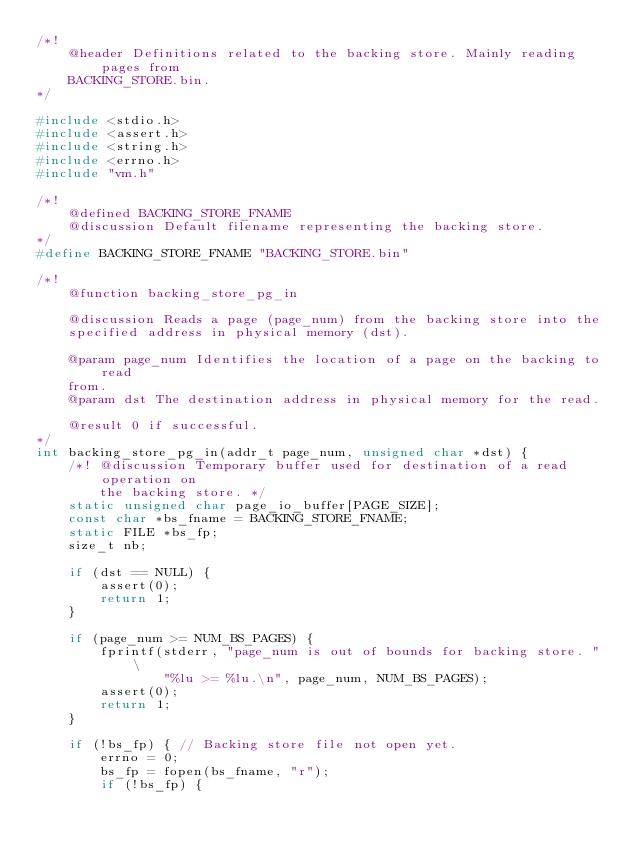<code> <loc_0><loc_0><loc_500><loc_500><_C_>/*!
    @header Definitions related to the backing store. Mainly reading pages from
    BACKING_STORE.bin.
*/

#include <stdio.h>
#include <assert.h>
#include <string.h>
#include <errno.h>
#include "vm.h"

/*!
    @defined BACKING_STORE_FNAME
    @discussion Default filename representing the backing store.
*/
#define BACKING_STORE_FNAME "BACKING_STORE.bin"

/*!
    @function backing_store_pg_in

    @discussion Reads a page (page_num) from the backing store into the
    specified address in physical memory (dst).

    @param page_num Identifies the location of a page on the backing to read
    from.
    @param dst The destination address in physical memory for the read.

    @result 0 if successful.
*/
int backing_store_pg_in(addr_t page_num, unsigned char *dst) {
    /*! @discussion Temporary buffer used for destination of a read operation on
        the backing store. */
    static unsigned char page_io_buffer[PAGE_SIZE];
    const char *bs_fname = BACKING_STORE_FNAME;
    static FILE *bs_fp;
    size_t nb;

    if (dst == NULL) {
        assert(0);
        return 1;
    }

    if (page_num >= NUM_BS_PAGES) {
        fprintf(stderr, "page_num is out of bounds for backing store. " \
                "%lu >= %lu.\n", page_num, NUM_BS_PAGES);
        assert(0);
        return 1;
    }

    if (!bs_fp) { // Backing store file not open yet.
        errno = 0;
        bs_fp = fopen(bs_fname, "r");
        if (!bs_fp) {</code> 